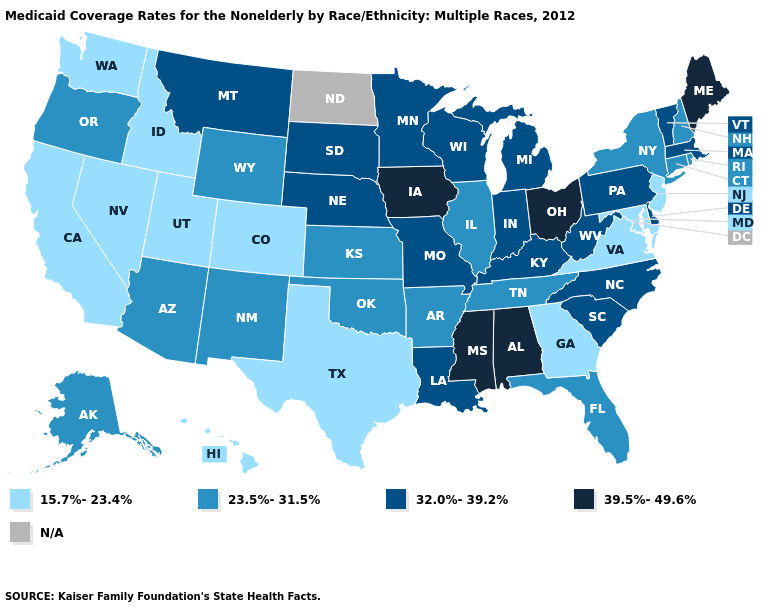What is the lowest value in the West?
Concise answer only. 15.7%-23.4%. What is the value of North Dakota?
Concise answer only. N/A. What is the value of North Carolina?
Short answer required. 32.0%-39.2%. Does the first symbol in the legend represent the smallest category?
Give a very brief answer. Yes. Which states have the lowest value in the USA?
Be succinct. California, Colorado, Georgia, Hawaii, Idaho, Maryland, Nevada, New Jersey, Texas, Utah, Virginia, Washington. Is the legend a continuous bar?
Short answer required. No. What is the lowest value in the USA?
Write a very short answer. 15.7%-23.4%. What is the highest value in the USA?
Concise answer only. 39.5%-49.6%. Name the states that have a value in the range 23.5%-31.5%?
Quick response, please. Alaska, Arizona, Arkansas, Connecticut, Florida, Illinois, Kansas, New Hampshire, New Mexico, New York, Oklahoma, Oregon, Rhode Island, Tennessee, Wyoming. Does the first symbol in the legend represent the smallest category?
Concise answer only. Yes. What is the value of Ohio?
Short answer required. 39.5%-49.6%. What is the lowest value in states that border Oklahoma?
Keep it brief. 15.7%-23.4%. What is the value of Iowa?
Be succinct. 39.5%-49.6%. What is the value of West Virginia?
Answer briefly. 32.0%-39.2%. 